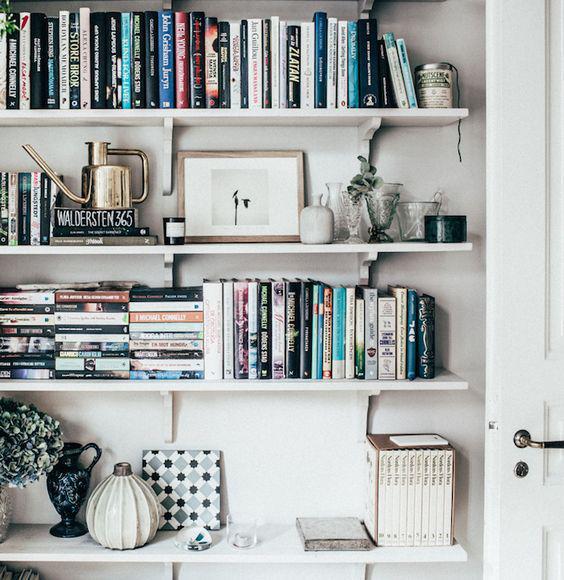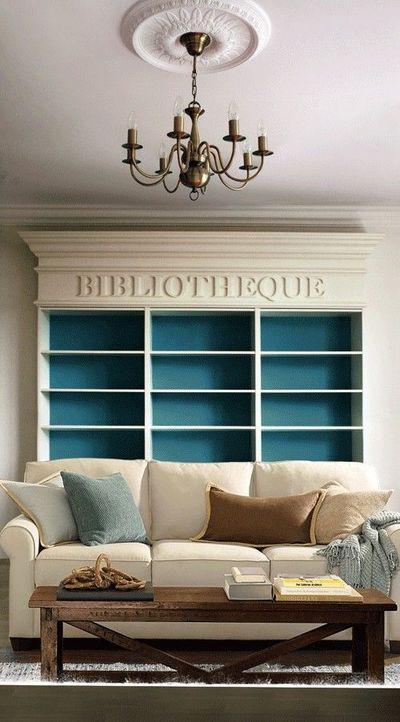The first image is the image on the left, the second image is the image on the right. For the images displayed, is the sentence "A tufted royal blue sofa is in front of a wall-filling bookcase that is not white." factually correct? Answer yes or no. No. 